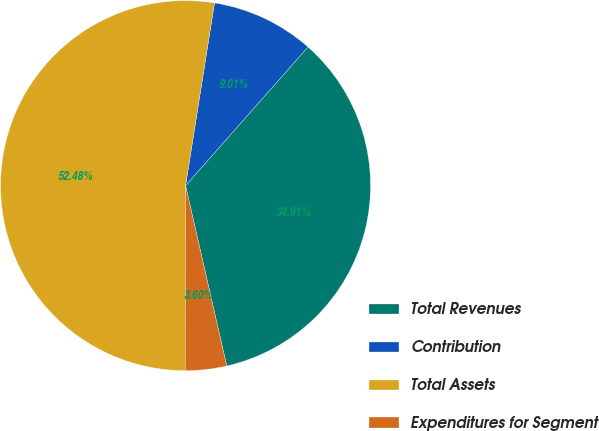<chart> <loc_0><loc_0><loc_500><loc_500><pie_chart><fcel>Total Revenues<fcel>Contribution<fcel>Total Assets<fcel>Expenditures for Segment<nl><fcel>34.91%<fcel>9.01%<fcel>52.47%<fcel>3.6%<nl></chart> 